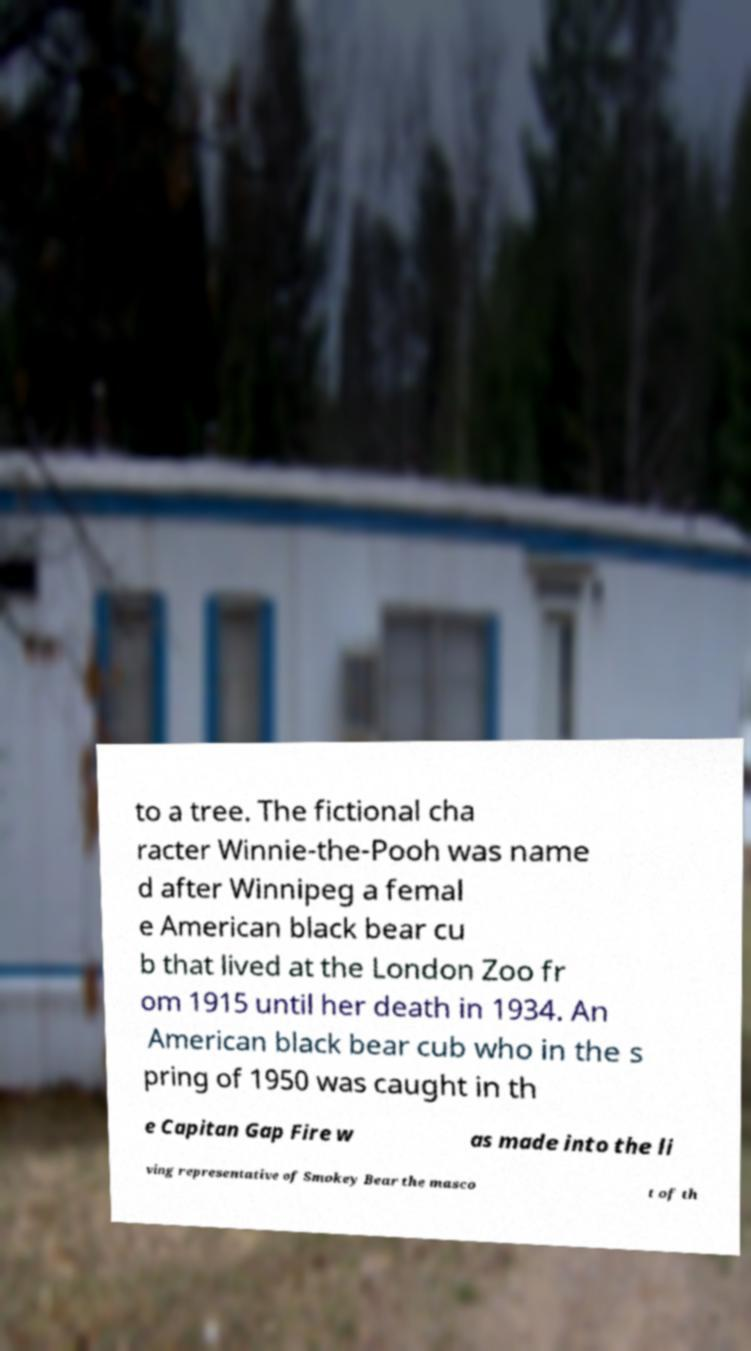There's text embedded in this image that I need extracted. Can you transcribe it verbatim? to a tree. The fictional cha racter Winnie-the-Pooh was name d after Winnipeg a femal e American black bear cu b that lived at the London Zoo fr om 1915 until her death in 1934. An American black bear cub who in the s pring of 1950 was caught in th e Capitan Gap Fire w as made into the li ving representative of Smokey Bear the masco t of th 